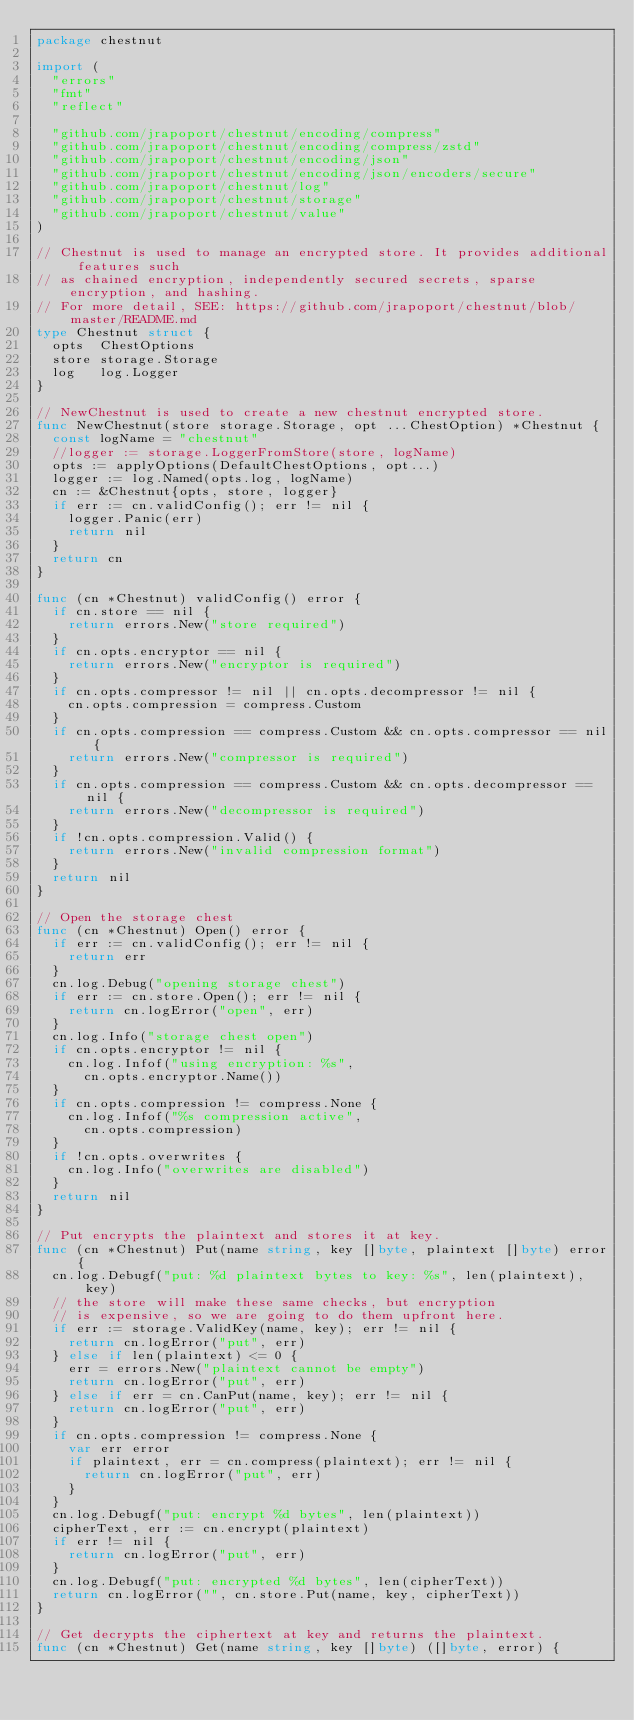Convert code to text. <code><loc_0><loc_0><loc_500><loc_500><_Go_>package chestnut

import (
	"errors"
	"fmt"
	"reflect"

	"github.com/jrapoport/chestnut/encoding/compress"
	"github.com/jrapoport/chestnut/encoding/compress/zstd"
	"github.com/jrapoport/chestnut/encoding/json"
	"github.com/jrapoport/chestnut/encoding/json/encoders/secure"
	"github.com/jrapoport/chestnut/log"
	"github.com/jrapoport/chestnut/storage"
	"github.com/jrapoport/chestnut/value"
)

// Chestnut is used to manage an encrypted store. It provides additional features such
// as chained encryption, independently secured secrets, sparse encryption, and hashing.
// For more detail, SEE: https://github.com/jrapoport/chestnut/blob/master/README.md
type Chestnut struct {
	opts  ChestOptions
	store storage.Storage
	log   log.Logger
}

// NewChestnut is used to create a new chestnut encrypted store.
func NewChestnut(store storage.Storage, opt ...ChestOption) *Chestnut {
	const logName = "chestnut"
	//logger := storage.LoggerFromStore(store, logName)
	opts := applyOptions(DefaultChestOptions, opt...)
	logger := log.Named(opts.log, logName)
	cn := &Chestnut{opts, store, logger}
	if err := cn.validConfig(); err != nil {
		logger.Panic(err)
		return nil
	}
	return cn
}

func (cn *Chestnut) validConfig() error {
	if cn.store == nil {
		return errors.New("store required")
	}
	if cn.opts.encryptor == nil {
		return errors.New("encryptor is required")
	}
	if cn.opts.compressor != nil || cn.opts.decompressor != nil {
		cn.opts.compression = compress.Custom
	}
	if cn.opts.compression == compress.Custom && cn.opts.compressor == nil {
		return errors.New("compressor is required")
	}
	if cn.opts.compression == compress.Custom && cn.opts.decompressor == nil {
		return errors.New("decompressor is required")
	}
	if !cn.opts.compression.Valid() {
		return errors.New("invalid compression format")
	}
	return nil
}

// Open the storage chest
func (cn *Chestnut) Open() error {
	if err := cn.validConfig(); err != nil {
		return err
	}
	cn.log.Debug("opening storage chest")
	if err := cn.store.Open(); err != nil {
		return cn.logError("open", err)
	}
	cn.log.Info("storage chest open")
	if cn.opts.encryptor != nil {
		cn.log.Infof("using encryption: %s",
			cn.opts.encryptor.Name())
	}
	if cn.opts.compression != compress.None {
		cn.log.Infof("%s compression active",
			cn.opts.compression)
	}
	if !cn.opts.overwrites {
		cn.log.Info("overwrites are disabled")
	}
	return nil
}

// Put encrypts the plaintext and stores it at key.
func (cn *Chestnut) Put(name string, key []byte, plaintext []byte) error {
	cn.log.Debugf("put: %d plaintext bytes to key: %s", len(plaintext), key)
	// the store will make these same checks, but encryption
	// is expensive, so we are going to do them upfront here.
	if err := storage.ValidKey(name, key); err != nil {
		return cn.logError("put", err)
	} else if len(plaintext) <= 0 {
		err = errors.New("plaintext cannot be empty")
		return cn.logError("put", err)
	} else if err = cn.CanPut(name, key); err != nil {
		return cn.logError("put", err)
	}
	if cn.opts.compression != compress.None {
		var err error
		if plaintext, err = cn.compress(plaintext); err != nil {
			return cn.logError("put", err)
		}
	}
	cn.log.Debugf("put: encrypt %d bytes", len(plaintext))
	cipherText, err := cn.encrypt(plaintext)
	if err != nil {
		return cn.logError("put", err)
	}
	cn.log.Debugf("put: encrypted %d bytes", len(cipherText))
	return cn.logError("", cn.store.Put(name, key, cipherText))
}

// Get decrypts the ciphertext at key and returns the plaintext.
func (cn *Chestnut) Get(name string, key []byte) ([]byte, error) {</code> 